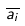<formula> <loc_0><loc_0><loc_500><loc_500>\overline { a _ { i } }</formula> 